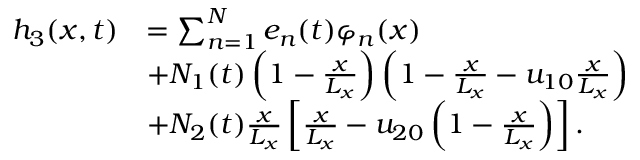Convert formula to latex. <formula><loc_0><loc_0><loc_500><loc_500>\begin{array} { r l } { h _ { 3 } ( x , t ) } & { = \sum _ { n = 1 } ^ { N } e _ { n } ( t ) \varphi _ { n } ( x ) } \\ & { + N _ { 1 } ( t ) \left ( 1 - \frac { x } { L _ { x } } \right ) \left ( 1 - \frac { x } { L _ { x } } - u _ { 1 0 } \frac { x } { L _ { x } } \right ) } \\ & { + N _ { 2 } ( t ) \frac { x } { L _ { x } } \left [ \frac { x } { L _ { x } } - u _ { 2 0 } \left ( 1 - \frac { x } { L _ { x } } \right ) \right ] . } \end{array}</formula> 